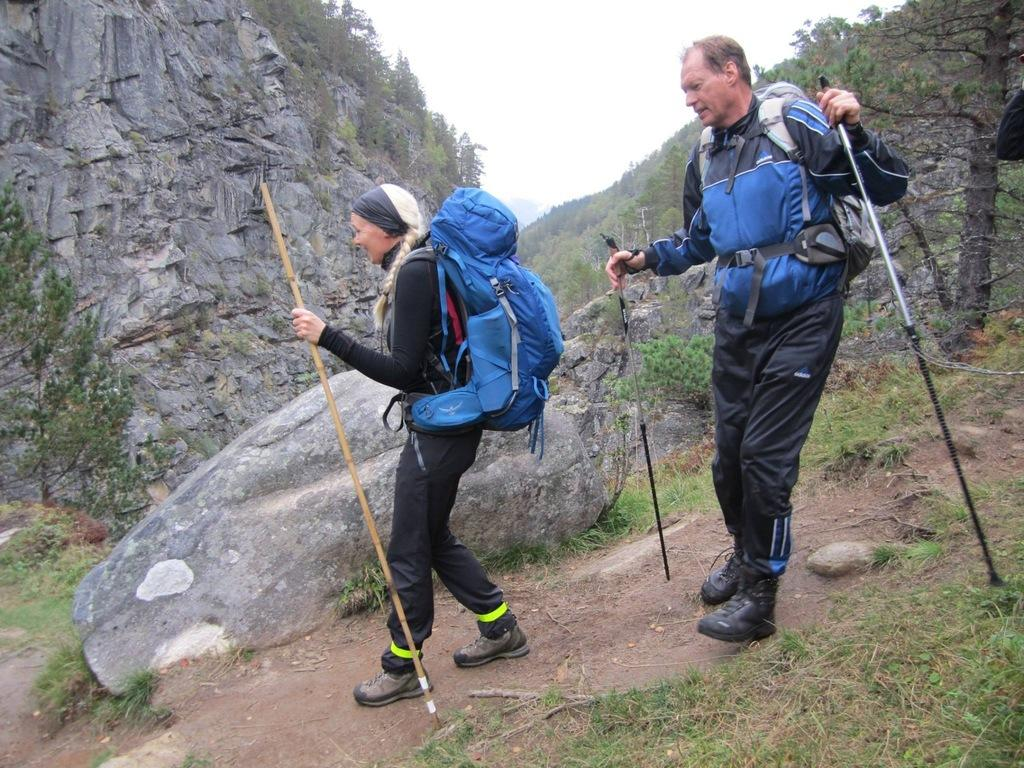How many people are in the image? There are people in the image, but the exact number is not specified. What are the people wearing in the image? The people are wearing bags in the image. What are the people holding in the image? The people are holding sticks in the image. What type of natural feature can be seen in the image? There is a mountain in the image. What type of terrain is present in the image? Rocks and grass are present in the image. What type of vegetation is visible in the image? Trees are visible in the image. What is visible in the background of the image? The sky is visible in the background of the image. What type of quilt is being used by the dinosaurs in the image? There are no dinosaurs present in the image, and therefore no quilt can be associated with them. 